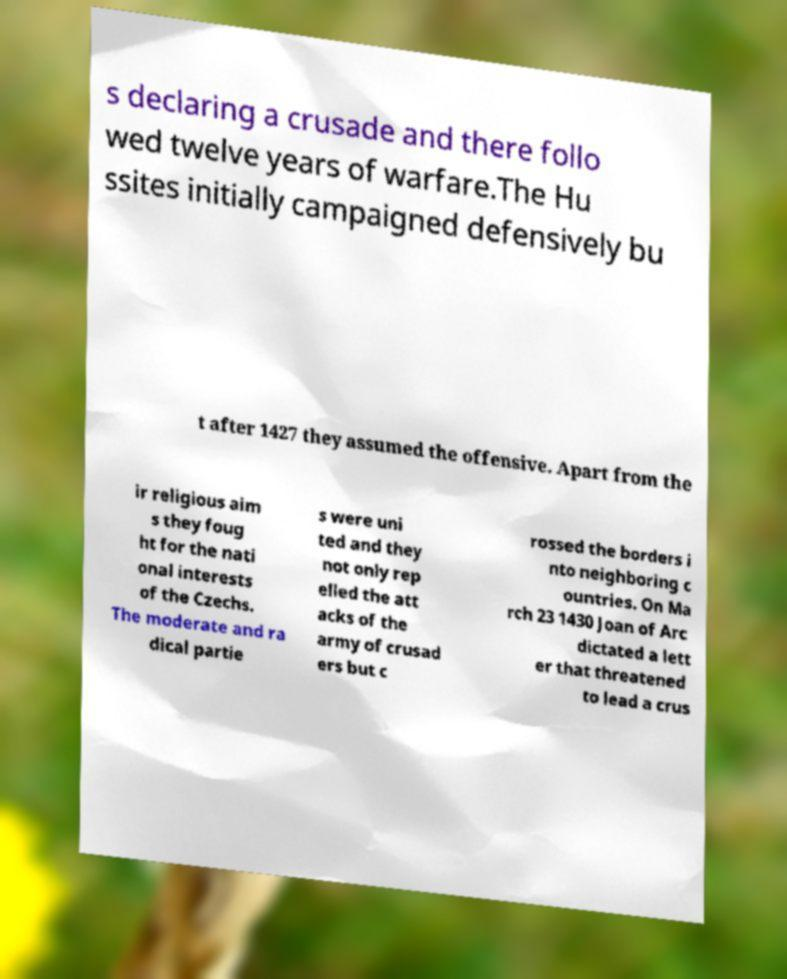What messages or text are displayed in this image? I need them in a readable, typed format. s declaring a crusade and there follo wed twelve years of warfare.The Hu ssites initially campaigned defensively bu t after 1427 they assumed the offensive. Apart from the ir religious aim s they foug ht for the nati onal interests of the Czechs. The moderate and ra dical partie s were uni ted and they not only rep elled the att acks of the army of crusad ers but c rossed the borders i nto neighboring c ountries. On Ma rch 23 1430 Joan of Arc dictated a lett er that threatened to lead a crus 